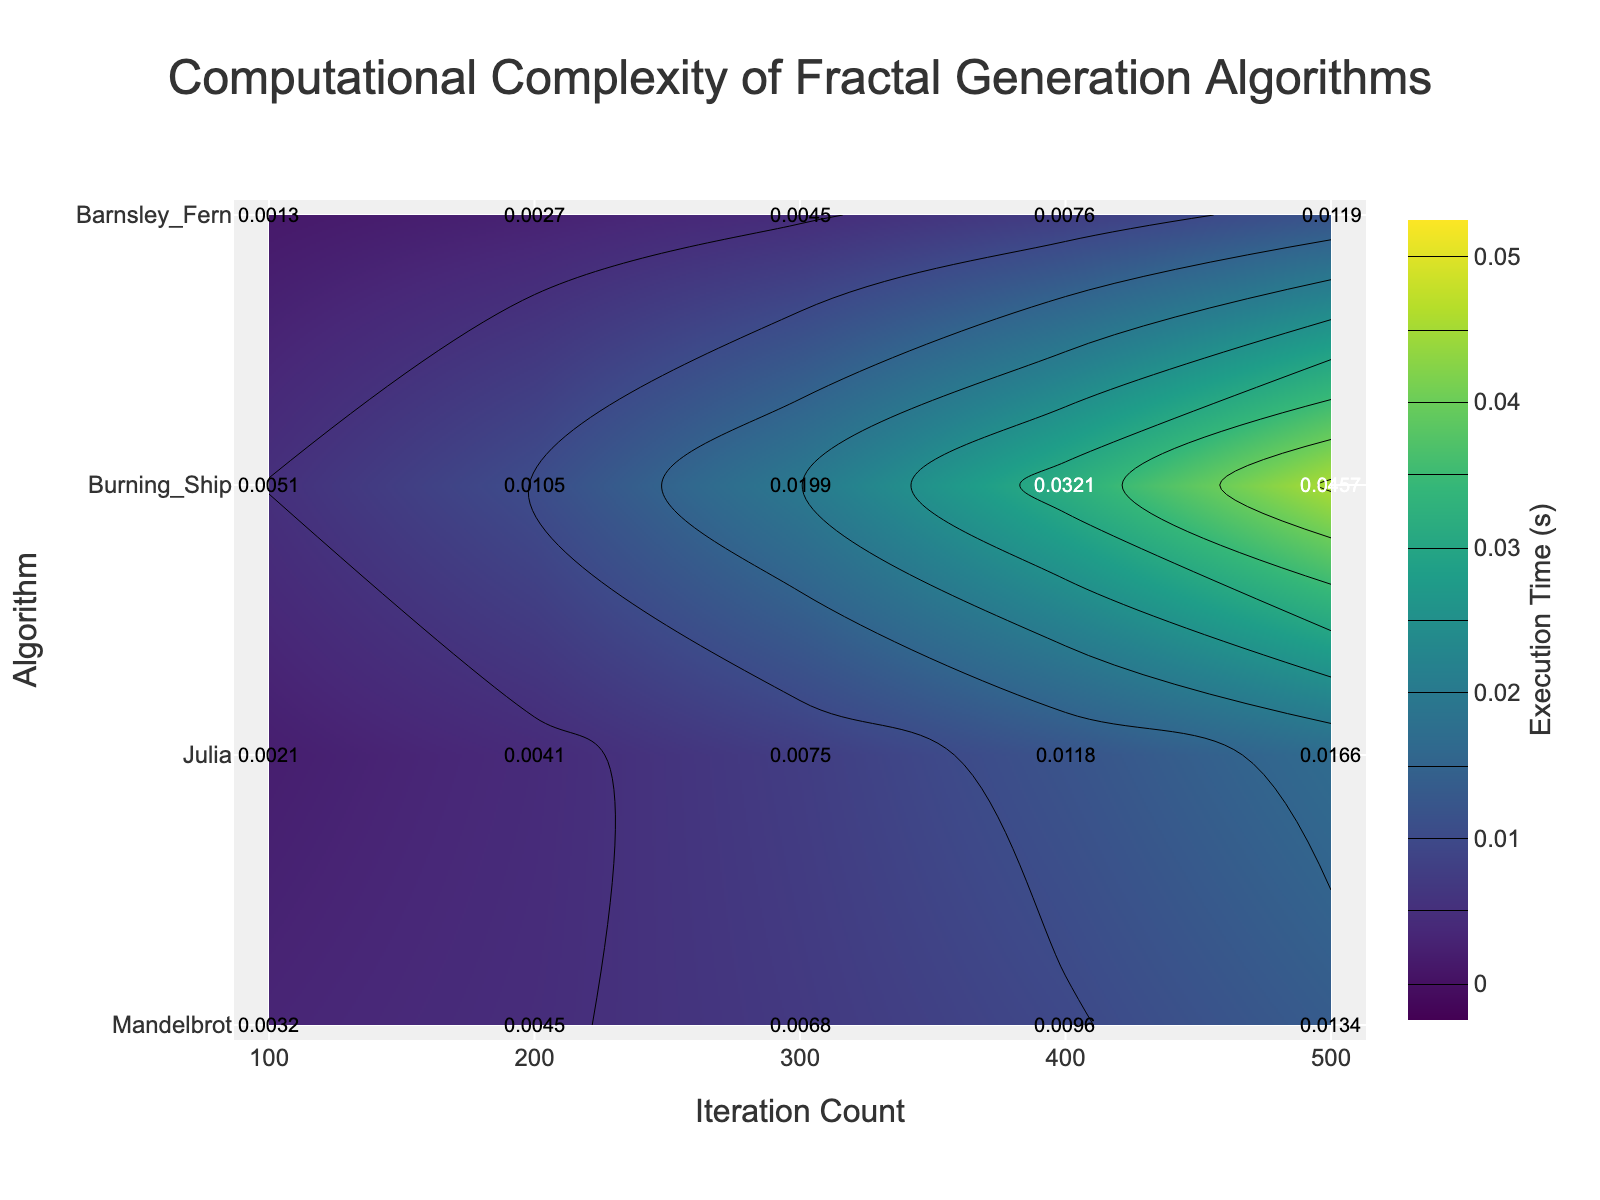What is the execution time for the Mandelbrot algorithm at 300 iterations? Look at the Mandelbrot row and trace horizontally to the 300 iterations column. The value at the intersection indicates the execution time.
Answer: 0.0068 Which algorithm has the highest execution time at 500 iterations? Look at the 500 iterations column and identify the highest value. It falls in the Burning_Ship row, signifying the Burning_Ship algorithm.
Answer: Burning_Ship What is the average execution time for the Julia algorithm across all iterations? Sum the execution times for the Julia algorithm and divide by the number of data points (5). The values are 0.0021, 0.0041, 0.0075, 0.0118, and 0.0166. \( (0.0021 + 0.0041 + 0.0075 + 0.0118 + 0.0166) / 5 = 0.00842 \)
Answer: 0.0084 Which algorithm shows the largest increase in execution time from 100 to 500 iterations? Calculate the difference in execution time between 100 and 500 iterations for each algorithm. Observe the changes: Mandelbrot: 0.0134 - 0.0032 = 0.0102, Julia: 0.0166 - 0.0021 = 0.0145, Burning_Ship: 0.0457 - 0.0051 = 0.0406, Barnsley_Fern: 0.0119 - 0.0013 = 0.0106. Burning_Ship has the largest increase.
Answer: Burning_Ship What is the contour plot's color scale range for execution time? Refer to the color bar on the side of the plot, which indicates the range of execution time values from start to end.
Answer: 0 to 0.05 seconds How does the Barnsley_Fern's execution time at 400 iterations compare to the Julia algorithm's at the same iteration count? Compare the execution time values for Barnsley_Fern and Julia at 400 iterations, which are 0.0076 and 0.0118 respectively.
Answer: Barnsley_Fern < Julia Which algorithm has the smallest execution time at 200 iterations? Observe the execution times in the 200 iterations column. The smallest value is in the Barnsley_Fern row.
Answer: Barnsley_Fern At which iteration count does the Mandelbrot algorithm reach an execution time above 0.01 seconds? Check where the execution time for the Mandelbrot algorithm surpasses 0.01 seconds. It occurs at 500 iterations.
Answer: 500 What can you infer about the computational complexity of the Burning_Ship algorithm based on the contour plot? Observe that the Burning_Ship algorithm has generally higher execution times that increase more steeply with iterations compared to other algorithms, indicating higher computational complexity.
Answer: Higher complexity What is the total execution time for all algorithms at 300 iterations? Sum the execution times for all algorithms at 300 iterations. \( 0.0068 (Mandelbrot) + 0.0075 (Julia) + 0.0199 (Burning_Ship) + 0.0045 (Barnsley_Fern) = 0.0387 \)
Answer: 0.0387 